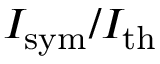Convert formula to latex. <formula><loc_0><loc_0><loc_500><loc_500>I _ { s y m } / I _ { t h }</formula> 